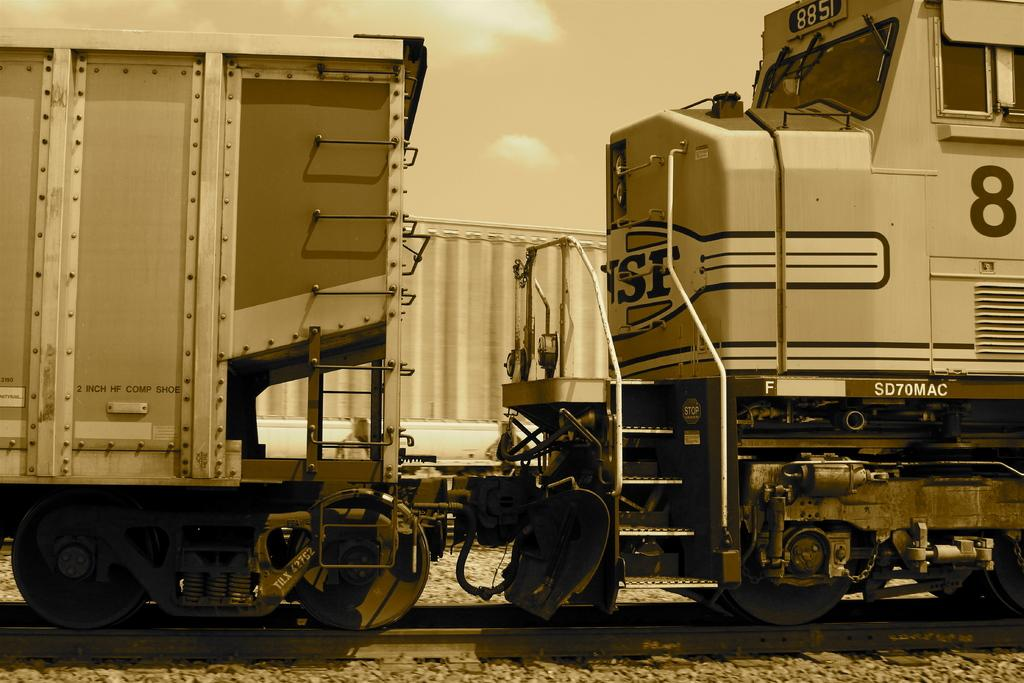What can be seen in the background of the image? The sky is visible in the image. What is present in the sky? There are clouds in the sky. What type of transportation is featured in the image? There are trains in the image. What is the context for the trains in the image? The trains are on a railway track in the image. What is the lip of the train doing in the image? There is no lip present on the train in the image. 